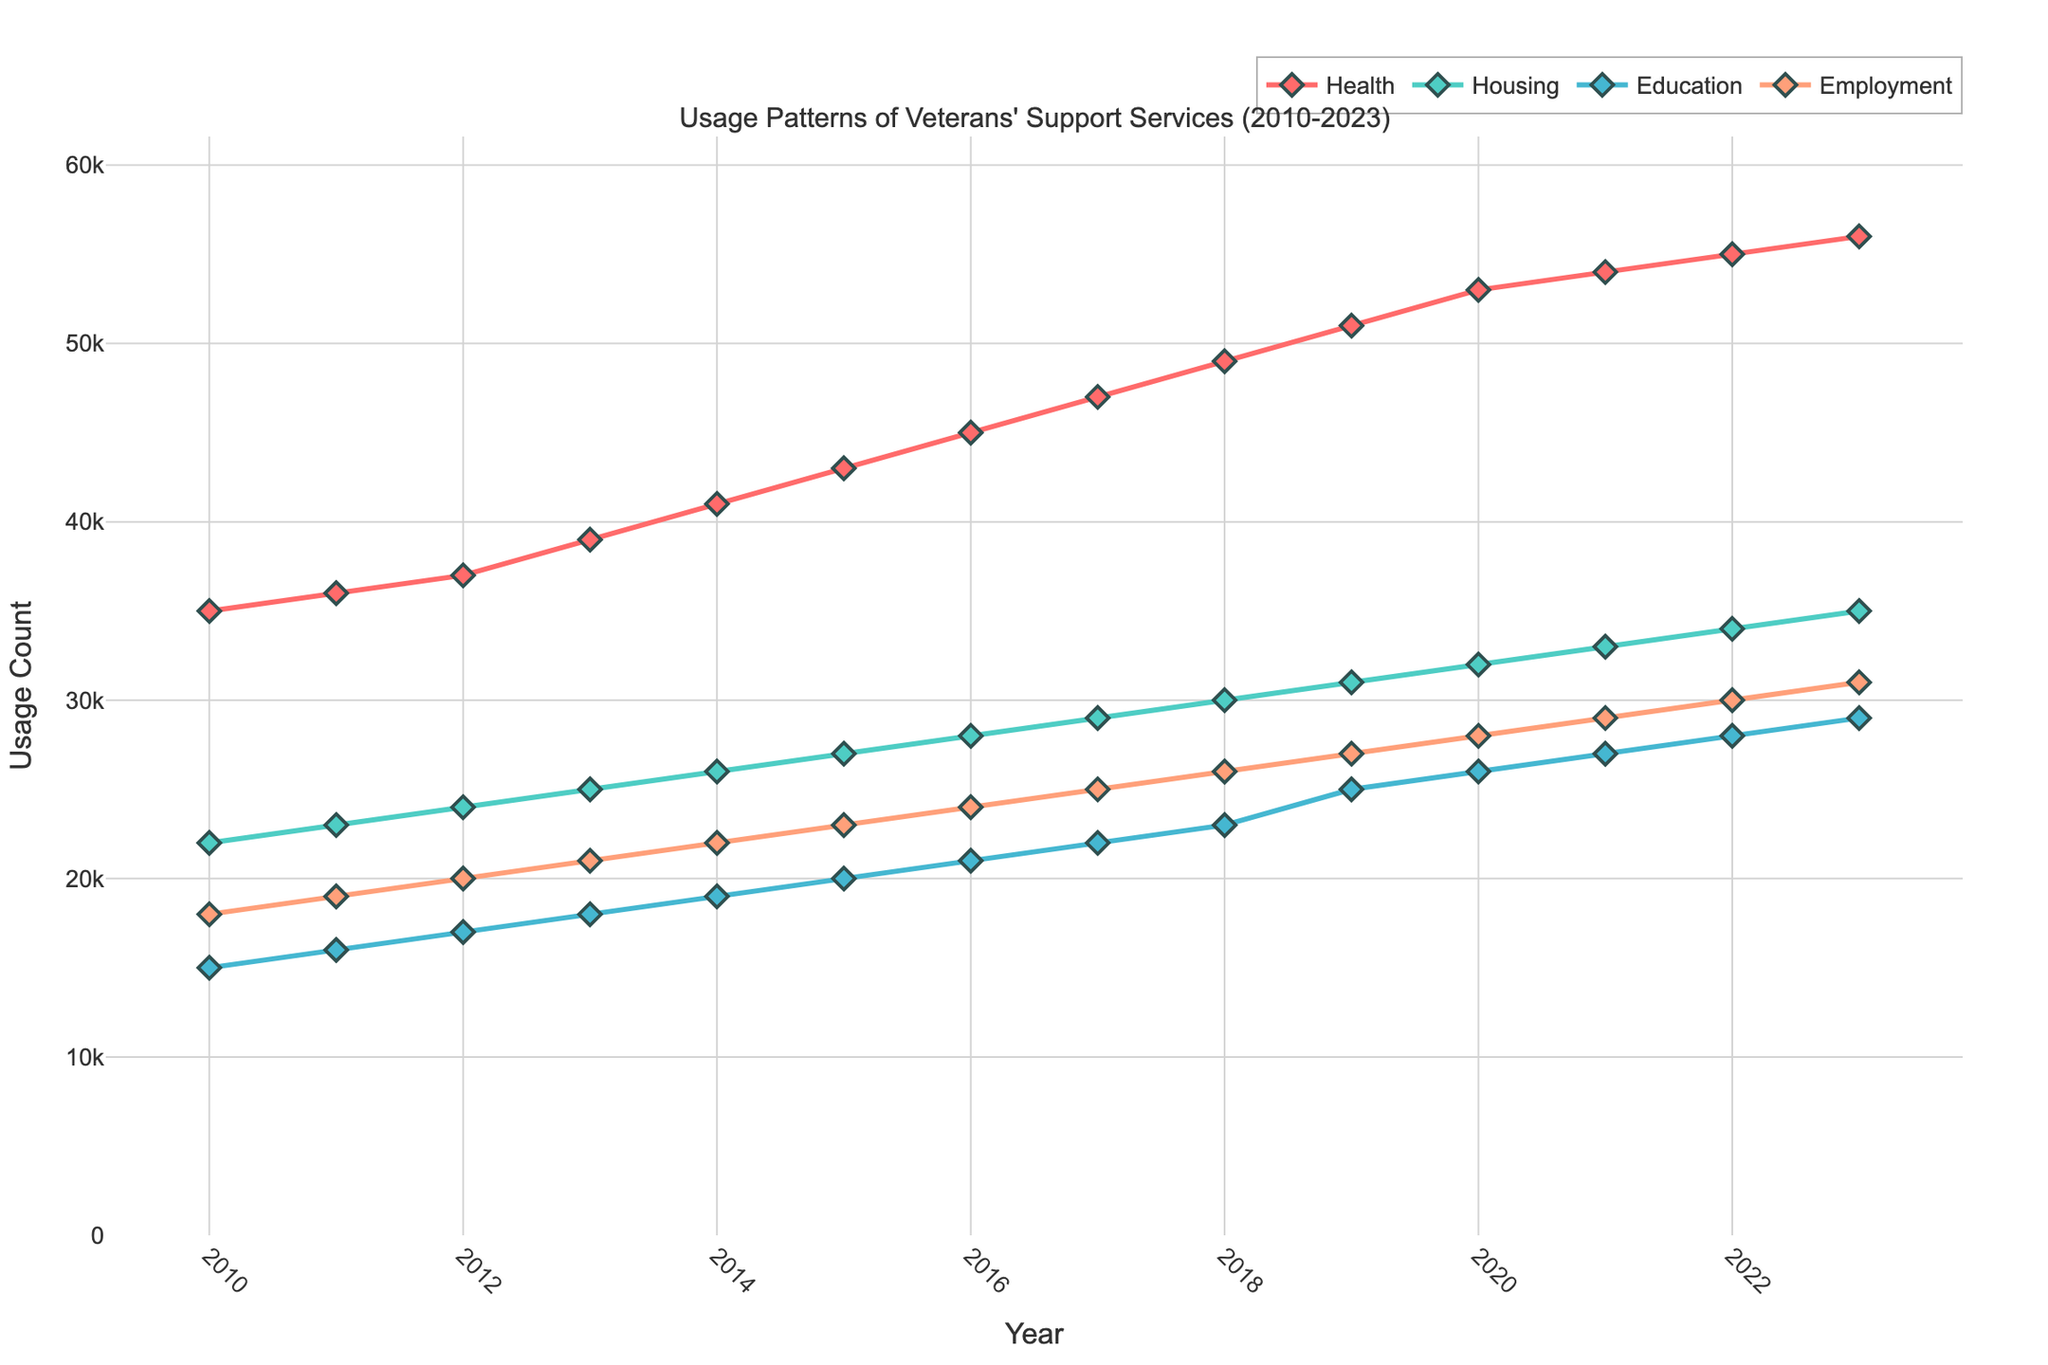What is the title of the figure? The title is usually located at the top of the figure, providing an overview of what the time series plot represents.
Answer: Usage Patterns of Veterans' Support Services (2010-2023) Which service type had the highest usage count in 2023? Look for the endpoint of each line representing different service types in the year 2023 and compare their values.
Answer: Health In which year did the Education service type first reach 20,000 usage counts? Trace the line for the Education service type and find the year where the usage count first crosses the 20,000 mark.
Answer: 2015 By how much did the Housing service usage increase from 2010 to 2023? Calculate the difference between the usage count for Housing in 2023 and that in 2010 by subtracting the earlier value from the later.
Answer: 13,000 Which year shows the biggest increase in Employment service usage compared to the previous year? Compare the increase in usage counts for Employment service between each pair of consecutive years and identify the year which had the largest increase.
Answer: 2011 What is the color used for the Health service type line in the plot? Check the color of the line that represents the Health service usage in the plot legend or directly in the plot area.
Answer: Red (FF6B6B) Did the Health service type ever experience a decrease in usage from one year to the next? Examine the trend of the Health service line for any segments where the usage count drops compared to the previous year.
Answer: No What is the average usage count for the Employment service type across all years? Add up the usage counts for Employment from 2010 to 2023 and divide by the number of years (14).
Answer: 23,214 Which two service types had equal usage counts in any year? Compare the usage counts of different service types for each year to identify any instances where two types have the same value.
Answer: None What is the overall trend in the usage of veterans' support services from 2010 to 2023? Analyze the general direction of the lines for all service types over the years, paying attention to the slopes and direction (increasing, decreasing, or stable).
Answer: Increasing 